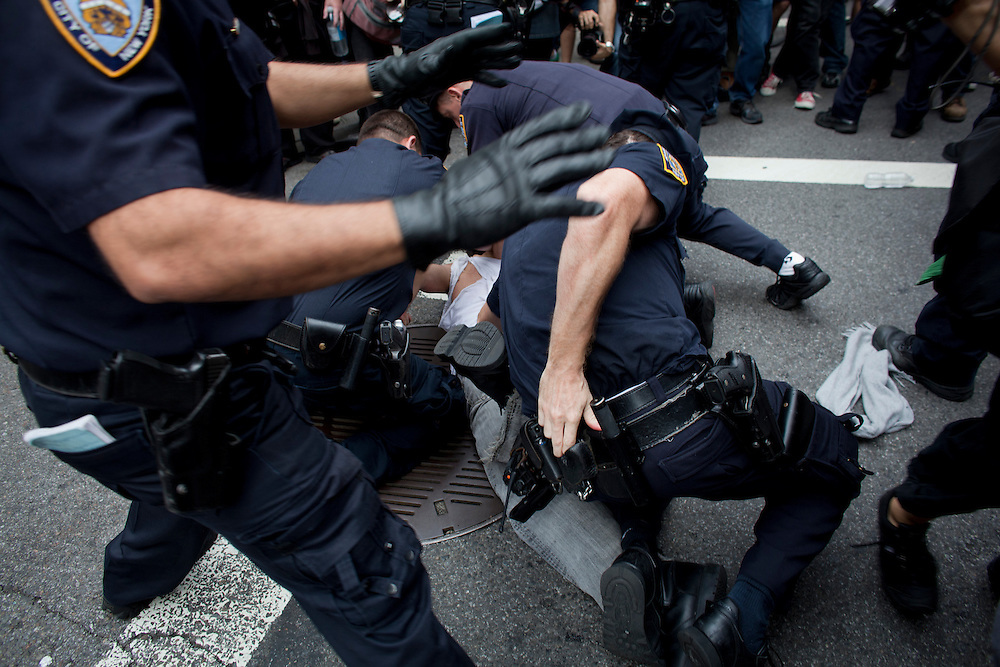If you had to write a fictional story based on this image, what would be the plot? In a bustling city known for its vibrant protests, a peaceful demonstration takes a sudden turn when a misunderstood activist is caught amidst a chaotic misunderstanding. The police rush in to subdue what they perceive as a threat, unaware that the individual is a key figure striving for change. As the story unfolds, secrets about the true intentions behind the activist's actions and the governing powers attempting to stifle their message are revealed. Through a series of tense interactions and heartfelt revelations, the narrative explores themes of justice, oppression, and the power of a single voice in the midst of societal upheaval. How might the subdued individual’s background contribute to their current predicament? The background of the subdued individual could play a crucial role in their current situation. Perhaps they have been a vocal advocate for a controversial cause, drawing both public support and authoritative scrutiny. Their prior involvement in organizing protests or public speaking might have put them on law enforcement's radar, especially in heightened political climates. Alternatively, they could be a reporter or a bystander who got caught in the chaos, their casual attire misleading authorities into misidentifying their role. Their history, whether as an activist, journalist, or civilian, shapes the narrative and underscores the complexities of societal conflicts and the fine line between order and justice. Imagine this scenario is set in a dystopian future where emotions are controlled by the state. How would this alter the dynamics of the scene? In a dystopian future where emotions are controlled by the state, the dynamics of this scene would be drastically different. The subdued individual might exhibit unusual calmness or passivity, a result of enforced emotional regulation. The police officers, too, might act with an unsettling precision devoid of any personal feelings, driven purely by state-imposed directives. This lack of natural emotional response could create a chilling, almost robotic atmosphere, where human reactions are stifled by the state's intervention. The struggle, therefore, would not just be physical but also an internal fight against emotional suppression, with the subdued individual possibly being part of a resistance that strives to regain emotional freedom. 